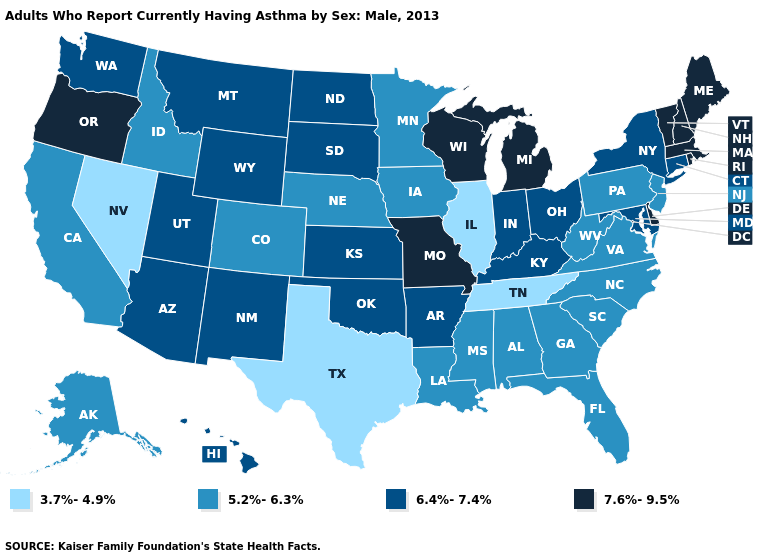What is the value of New York?
Concise answer only. 6.4%-7.4%. What is the highest value in states that border North Carolina?
Concise answer only. 5.2%-6.3%. What is the highest value in states that border Arkansas?
Write a very short answer. 7.6%-9.5%. What is the lowest value in the Northeast?
Give a very brief answer. 5.2%-6.3%. Does Hawaii have the highest value in the West?
Give a very brief answer. No. What is the value of Connecticut?
Short answer required. 6.4%-7.4%. Is the legend a continuous bar?
Quick response, please. No. What is the highest value in the Northeast ?
Write a very short answer. 7.6%-9.5%. What is the value of Nebraska?
Concise answer only. 5.2%-6.3%. Among the states that border Maine , which have the lowest value?
Concise answer only. New Hampshire. What is the lowest value in the USA?
Quick response, please. 3.7%-4.9%. Does Pennsylvania have the lowest value in the Northeast?
Keep it brief. Yes. What is the highest value in the USA?
Be succinct. 7.6%-9.5%. What is the value of Arizona?
Concise answer only. 6.4%-7.4%. 